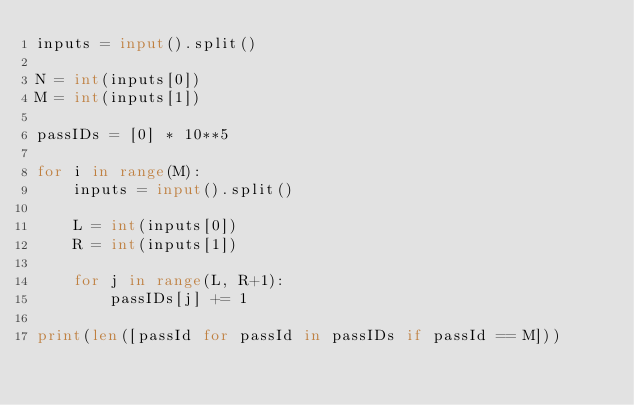<code> <loc_0><loc_0><loc_500><loc_500><_Python_>inputs = input().split()

N = int(inputs[0])
M = int(inputs[1])

passIDs = [0] * 10**5

for i in range(M):
    inputs = input().split()

    L = int(inputs[0])
    R = int(inputs[1])

    for j in range(L, R+1):
        passIDs[j] += 1

print(len([passId for passId in passIDs if passId == M]))

</code> 